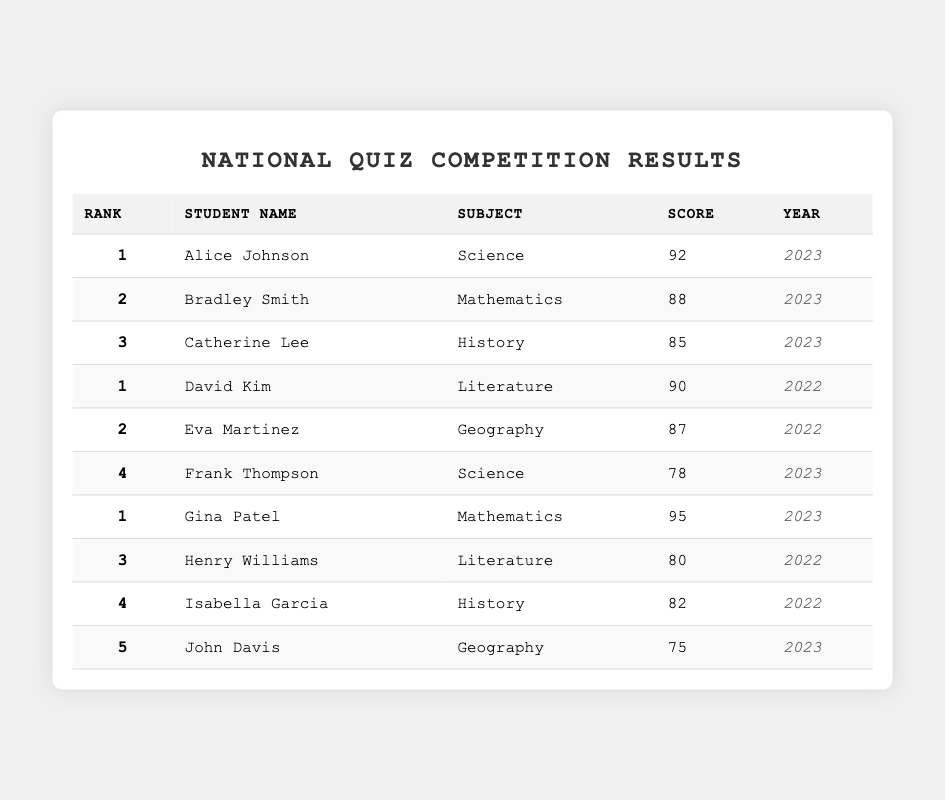What is the highest score in the 2023 quiz competition? Alice Johnson scored 92 in Science, which is the highest score listed for the year 2023 in the table.
Answer: 92 Which subject did Gina Patel compete in? The table clearly shows that Gina Patel competed in the subject of Mathematics.
Answer: Mathematics How many students scored above 80 in the 2023 competition? The students with scores above 80 in 2023 are Alice Johnson (92), Bradley Smith (88), and Gina Patel (95), making it three students total.
Answer: 3 Who ranked second in Mathematics for the year 2023? The table indicates that Bradley Smith ranked second with a score of 88 in the subject of Mathematics for the year 2023.
Answer: Bradley Smith What is the average score of students in Literature for 2022? The scores for Literature in 2022 are 90 (David Kim) and 80 (Henry Williams). The average score is (90 + 80) / 2 = 85.
Answer: 85 Did any student score below 80 in the 2023 competition? Yes, John Davis scored 75 in Geography, which is below 80 according to the table.
Answer: Yes Which student had the lowest rank in the Geography subject for 2023? John Davis is listed with a rank of 5 in Geography during the 2023 competition, making him the lowest-ranked in that subject.
Answer: John Davis How many subjects have students who scored more than 90? In the table, only the subject of Mathematics (Gina Patel with 95) and Science (Alice Johnson with 92) have scores above 90, totaling two subjects.
Answer: 2 Was Frank Thompson's score higher or lower than Catherine Lee's score in 2023? Frank Thompson scored 78, while Catherine Lee scored 85. Since 78 is lower than 85, Frank Thompson's score is lower.
Answer: Lower If we consider the years, which year had a higher highest score: 2023 or 2022? The highest score in 2023 is 95 by Gina Patel, while the highest score in 2022 is 90 by David Kim. Since 95 is greater than 90, 2023 had a higher highest score.
Answer: 2023 